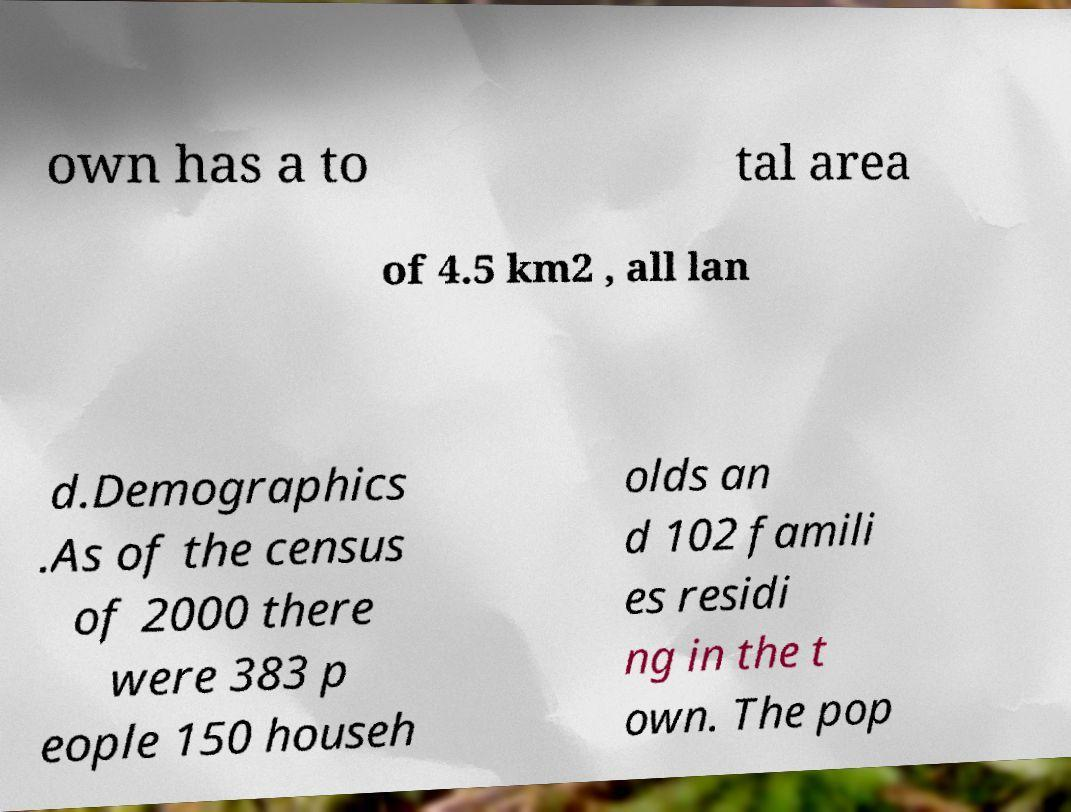Please read and relay the text visible in this image. What does it say? own has a to tal area of 4.5 km2 , all lan d.Demographics .As of the census of 2000 there were 383 p eople 150 househ olds an d 102 famili es residi ng in the t own. The pop 